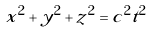<formula> <loc_0><loc_0><loc_500><loc_500>x ^ { 2 } + y ^ { 2 } + z ^ { 2 } = c ^ { 2 } t ^ { 2 }</formula> 